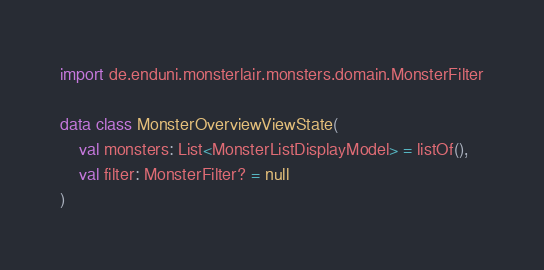Convert code to text. <code><loc_0><loc_0><loc_500><loc_500><_Kotlin_>import de.enduni.monsterlair.monsters.domain.MonsterFilter

data class MonsterOverviewViewState(
    val monsters: List<MonsterListDisplayModel> = listOf(),
    val filter: MonsterFilter? = null
)</code> 